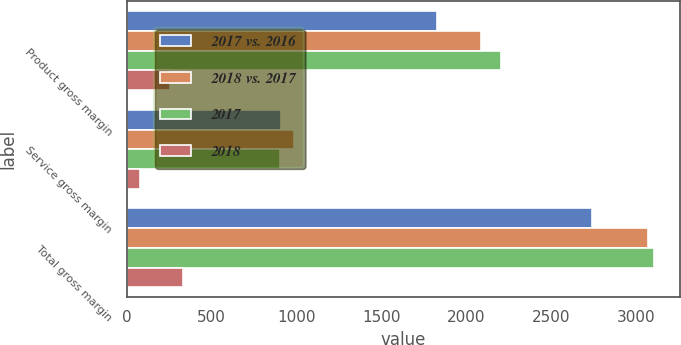Convert chart. <chart><loc_0><loc_0><loc_500><loc_500><stacked_bar_chart><ecel><fcel>Product gross margin<fcel>Service gross margin<fcel>Total gross margin<nl><fcel>2017 vs. 2016<fcel>1829.9<fcel>911.3<fcel>2741.2<nl><fcel>2018 vs. 2017<fcel>2085.3<fcel>986.8<fcel>3072.1<nl><fcel>2017<fcel>2202.7<fcel>901.8<fcel>3104.5<nl><fcel>2018<fcel>255.4<fcel>75.5<fcel>330.9<nl></chart> 